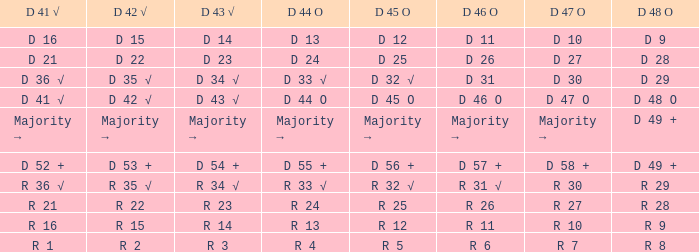Name the D 48 O with D 41 √ of d 41 √ D 48 O. 